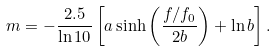Convert formula to latex. <formula><loc_0><loc_0><loc_500><loc_500>m = - \frac { 2 . 5 } { \ln 1 0 } \left [ a \sinh \left ( \frac { f / f _ { 0 } } { 2 b } \right ) + \ln b \right ] .</formula> 